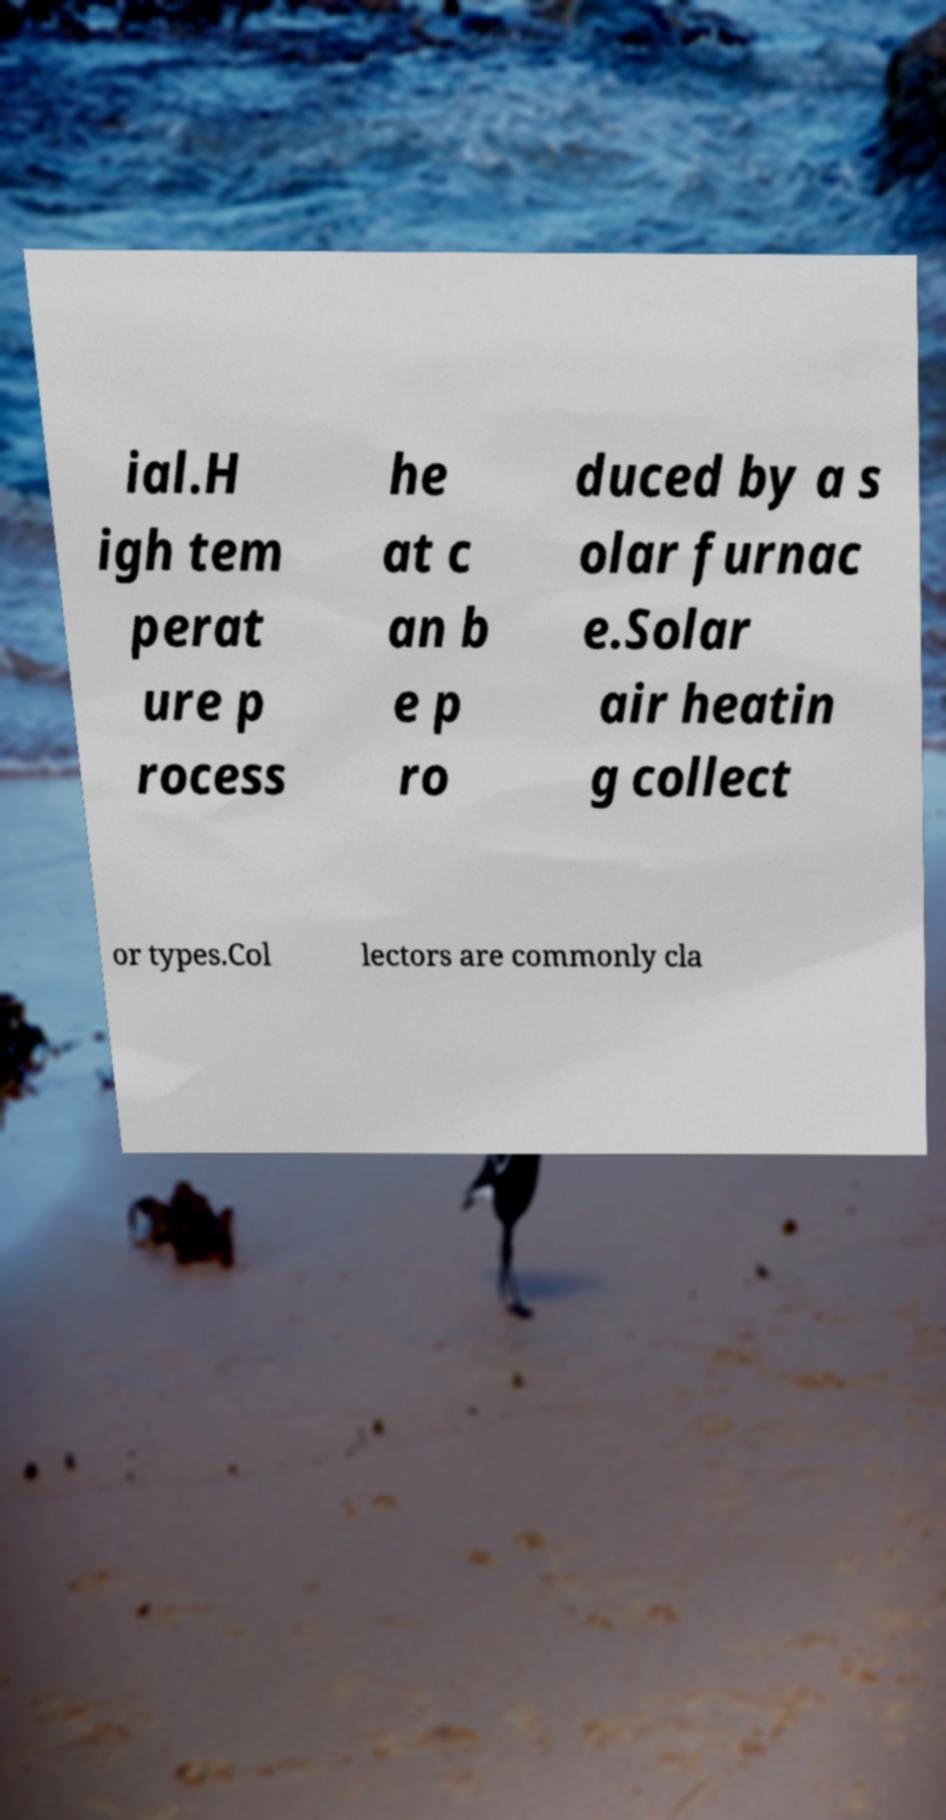What messages or text are displayed in this image? I need them in a readable, typed format. ial.H igh tem perat ure p rocess he at c an b e p ro duced by a s olar furnac e.Solar air heatin g collect or types.Col lectors are commonly cla 